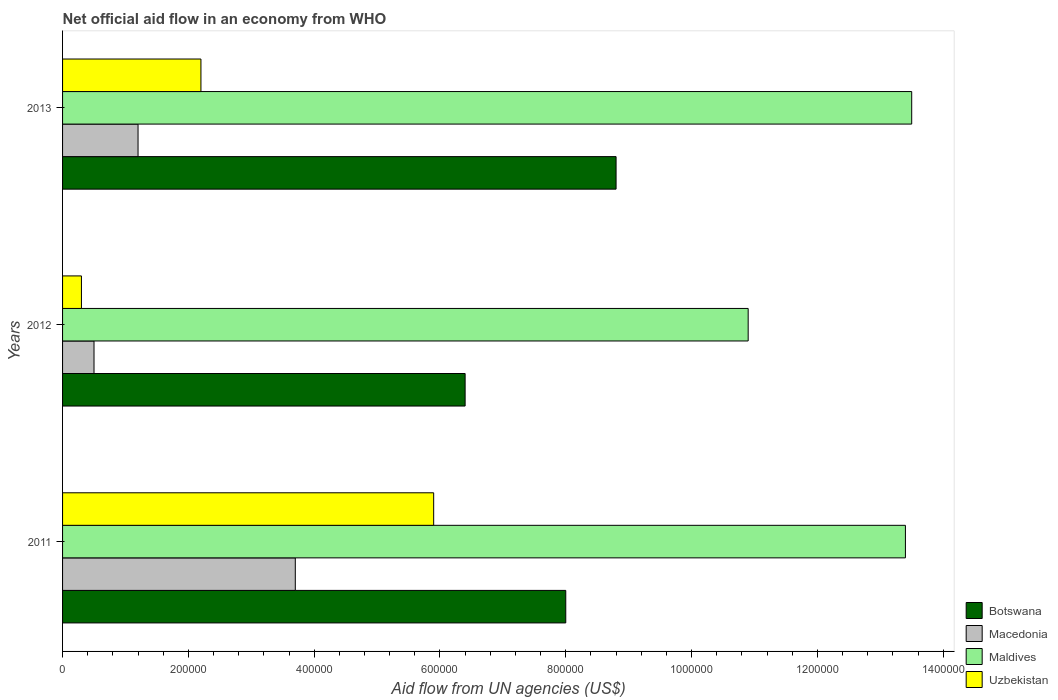How many different coloured bars are there?
Your answer should be very brief. 4. Are the number of bars per tick equal to the number of legend labels?
Keep it short and to the point. Yes. Are the number of bars on each tick of the Y-axis equal?
Provide a short and direct response. Yes. How many bars are there on the 3rd tick from the top?
Provide a short and direct response. 4. How many bars are there on the 1st tick from the bottom?
Your response must be concise. 4. What is the label of the 1st group of bars from the top?
Offer a terse response. 2013. In how many cases, is the number of bars for a given year not equal to the number of legend labels?
Provide a short and direct response. 0. What is the net official aid flow in Uzbekistan in 2013?
Your answer should be very brief. 2.20e+05. Across all years, what is the maximum net official aid flow in Maldives?
Your answer should be compact. 1.35e+06. What is the total net official aid flow in Maldives in the graph?
Offer a very short reply. 3.78e+06. What is the difference between the net official aid flow in Botswana in 2011 and that in 2013?
Your answer should be very brief. -8.00e+04. What is the difference between the net official aid flow in Uzbekistan in 2011 and the net official aid flow in Macedonia in 2012?
Ensure brevity in your answer.  5.40e+05. What is the average net official aid flow in Maldives per year?
Keep it short and to the point. 1.26e+06. What is the ratio of the net official aid flow in Botswana in 2011 to that in 2013?
Your answer should be very brief. 0.91. What is the difference between the highest and the second highest net official aid flow in Botswana?
Your response must be concise. 8.00e+04. Is the sum of the net official aid flow in Maldives in 2011 and 2013 greater than the maximum net official aid flow in Macedonia across all years?
Provide a short and direct response. Yes. Is it the case that in every year, the sum of the net official aid flow in Maldives and net official aid flow in Uzbekistan is greater than the sum of net official aid flow in Macedonia and net official aid flow in Botswana?
Your answer should be compact. Yes. What does the 1st bar from the top in 2011 represents?
Offer a terse response. Uzbekistan. What does the 4th bar from the bottom in 2012 represents?
Provide a short and direct response. Uzbekistan. Are all the bars in the graph horizontal?
Provide a succinct answer. Yes. How many years are there in the graph?
Keep it short and to the point. 3. Are the values on the major ticks of X-axis written in scientific E-notation?
Offer a terse response. No. Does the graph contain any zero values?
Make the answer very short. No. Does the graph contain grids?
Your answer should be very brief. No. What is the title of the graph?
Keep it short and to the point. Net official aid flow in an economy from WHO. Does "Mongolia" appear as one of the legend labels in the graph?
Your response must be concise. No. What is the label or title of the X-axis?
Offer a very short reply. Aid flow from UN agencies (US$). What is the label or title of the Y-axis?
Your answer should be compact. Years. What is the Aid flow from UN agencies (US$) in Botswana in 2011?
Give a very brief answer. 8.00e+05. What is the Aid flow from UN agencies (US$) of Maldives in 2011?
Keep it short and to the point. 1.34e+06. What is the Aid flow from UN agencies (US$) of Uzbekistan in 2011?
Provide a succinct answer. 5.90e+05. What is the Aid flow from UN agencies (US$) in Botswana in 2012?
Your response must be concise. 6.40e+05. What is the Aid flow from UN agencies (US$) in Maldives in 2012?
Your answer should be very brief. 1.09e+06. What is the Aid flow from UN agencies (US$) of Botswana in 2013?
Make the answer very short. 8.80e+05. What is the Aid flow from UN agencies (US$) of Maldives in 2013?
Keep it short and to the point. 1.35e+06. What is the Aid flow from UN agencies (US$) of Uzbekistan in 2013?
Your answer should be very brief. 2.20e+05. Across all years, what is the maximum Aid flow from UN agencies (US$) of Botswana?
Offer a terse response. 8.80e+05. Across all years, what is the maximum Aid flow from UN agencies (US$) of Maldives?
Provide a succinct answer. 1.35e+06. Across all years, what is the maximum Aid flow from UN agencies (US$) in Uzbekistan?
Make the answer very short. 5.90e+05. Across all years, what is the minimum Aid flow from UN agencies (US$) of Botswana?
Give a very brief answer. 6.40e+05. Across all years, what is the minimum Aid flow from UN agencies (US$) in Macedonia?
Your answer should be compact. 5.00e+04. Across all years, what is the minimum Aid flow from UN agencies (US$) of Maldives?
Offer a terse response. 1.09e+06. Across all years, what is the minimum Aid flow from UN agencies (US$) in Uzbekistan?
Make the answer very short. 3.00e+04. What is the total Aid flow from UN agencies (US$) of Botswana in the graph?
Provide a short and direct response. 2.32e+06. What is the total Aid flow from UN agencies (US$) of Macedonia in the graph?
Make the answer very short. 5.40e+05. What is the total Aid flow from UN agencies (US$) in Maldives in the graph?
Provide a short and direct response. 3.78e+06. What is the total Aid flow from UN agencies (US$) of Uzbekistan in the graph?
Offer a terse response. 8.40e+05. What is the difference between the Aid flow from UN agencies (US$) in Botswana in 2011 and that in 2012?
Offer a terse response. 1.60e+05. What is the difference between the Aid flow from UN agencies (US$) in Macedonia in 2011 and that in 2012?
Offer a very short reply. 3.20e+05. What is the difference between the Aid flow from UN agencies (US$) in Uzbekistan in 2011 and that in 2012?
Your response must be concise. 5.60e+05. What is the difference between the Aid flow from UN agencies (US$) in Botswana in 2011 and that in 2013?
Ensure brevity in your answer.  -8.00e+04. What is the difference between the Aid flow from UN agencies (US$) of Macedonia in 2011 and that in 2013?
Offer a terse response. 2.50e+05. What is the difference between the Aid flow from UN agencies (US$) of Maldives in 2011 and that in 2013?
Ensure brevity in your answer.  -10000. What is the difference between the Aid flow from UN agencies (US$) in Macedonia in 2012 and that in 2013?
Your answer should be very brief. -7.00e+04. What is the difference between the Aid flow from UN agencies (US$) of Botswana in 2011 and the Aid flow from UN agencies (US$) of Macedonia in 2012?
Your answer should be compact. 7.50e+05. What is the difference between the Aid flow from UN agencies (US$) of Botswana in 2011 and the Aid flow from UN agencies (US$) of Maldives in 2012?
Ensure brevity in your answer.  -2.90e+05. What is the difference between the Aid flow from UN agencies (US$) of Botswana in 2011 and the Aid flow from UN agencies (US$) of Uzbekistan in 2012?
Offer a very short reply. 7.70e+05. What is the difference between the Aid flow from UN agencies (US$) of Macedonia in 2011 and the Aid flow from UN agencies (US$) of Maldives in 2012?
Your answer should be compact. -7.20e+05. What is the difference between the Aid flow from UN agencies (US$) of Maldives in 2011 and the Aid flow from UN agencies (US$) of Uzbekistan in 2012?
Give a very brief answer. 1.31e+06. What is the difference between the Aid flow from UN agencies (US$) of Botswana in 2011 and the Aid flow from UN agencies (US$) of Macedonia in 2013?
Your answer should be very brief. 6.80e+05. What is the difference between the Aid flow from UN agencies (US$) in Botswana in 2011 and the Aid flow from UN agencies (US$) in Maldives in 2013?
Make the answer very short. -5.50e+05. What is the difference between the Aid flow from UN agencies (US$) of Botswana in 2011 and the Aid flow from UN agencies (US$) of Uzbekistan in 2013?
Keep it short and to the point. 5.80e+05. What is the difference between the Aid flow from UN agencies (US$) in Macedonia in 2011 and the Aid flow from UN agencies (US$) in Maldives in 2013?
Your response must be concise. -9.80e+05. What is the difference between the Aid flow from UN agencies (US$) in Macedonia in 2011 and the Aid flow from UN agencies (US$) in Uzbekistan in 2013?
Provide a short and direct response. 1.50e+05. What is the difference between the Aid flow from UN agencies (US$) in Maldives in 2011 and the Aid flow from UN agencies (US$) in Uzbekistan in 2013?
Provide a succinct answer. 1.12e+06. What is the difference between the Aid flow from UN agencies (US$) in Botswana in 2012 and the Aid flow from UN agencies (US$) in Macedonia in 2013?
Ensure brevity in your answer.  5.20e+05. What is the difference between the Aid flow from UN agencies (US$) in Botswana in 2012 and the Aid flow from UN agencies (US$) in Maldives in 2013?
Your answer should be very brief. -7.10e+05. What is the difference between the Aid flow from UN agencies (US$) of Macedonia in 2012 and the Aid flow from UN agencies (US$) of Maldives in 2013?
Keep it short and to the point. -1.30e+06. What is the difference between the Aid flow from UN agencies (US$) in Maldives in 2012 and the Aid flow from UN agencies (US$) in Uzbekistan in 2013?
Give a very brief answer. 8.70e+05. What is the average Aid flow from UN agencies (US$) in Botswana per year?
Ensure brevity in your answer.  7.73e+05. What is the average Aid flow from UN agencies (US$) of Maldives per year?
Ensure brevity in your answer.  1.26e+06. What is the average Aid flow from UN agencies (US$) of Uzbekistan per year?
Offer a terse response. 2.80e+05. In the year 2011, what is the difference between the Aid flow from UN agencies (US$) of Botswana and Aid flow from UN agencies (US$) of Maldives?
Keep it short and to the point. -5.40e+05. In the year 2011, what is the difference between the Aid flow from UN agencies (US$) of Macedonia and Aid flow from UN agencies (US$) of Maldives?
Your answer should be compact. -9.70e+05. In the year 2011, what is the difference between the Aid flow from UN agencies (US$) of Maldives and Aid flow from UN agencies (US$) of Uzbekistan?
Your answer should be very brief. 7.50e+05. In the year 2012, what is the difference between the Aid flow from UN agencies (US$) in Botswana and Aid flow from UN agencies (US$) in Macedonia?
Make the answer very short. 5.90e+05. In the year 2012, what is the difference between the Aid flow from UN agencies (US$) of Botswana and Aid flow from UN agencies (US$) of Maldives?
Your answer should be very brief. -4.50e+05. In the year 2012, what is the difference between the Aid flow from UN agencies (US$) in Macedonia and Aid flow from UN agencies (US$) in Maldives?
Provide a short and direct response. -1.04e+06. In the year 2012, what is the difference between the Aid flow from UN agencies (US$) of Maldives and Aid flow from UN agencies (US$) of Uzbekistan?
Ensure brevity in your answer.  1.06e+06. In the year 2013, what is the difference between the Aid flow from UN agencies (US$) of Botswana and Aid flow from UN agencies (US$) of Macedonia?
Offer a terse response. 7.60e+05. In the year 2013, what is the difference between the Aid flow from UN agencies (US$) in Botswana and Aid flow from UN agencies (US$) in Maldives?
Offer a very short reply. -4.70e+05. In the year 2013, what is the difference between the Aid flow from UN agencies (US$) of Botswana and Aid flow from UN agencies (US$) of Uzbekistan?
Offer a terse response. 6.60e+05. In the year 2013, what is the difference between the Aid flow from UN agencies (US$) of Macedonia and Aid flow from UN agencies (US$) of Maldives?
Your answer should be compact. -1.23e+06. In the year 2013, what is the difference between the Aid flow from UN agencies (US$) of Maldives and Aid flow from UN agencies (US$) of Uzbekistan?
Ensure brevity in your answer.  1.13e+06. What is the ratio of the Aid flow from UN agencies (US$) in Botswana in 2011 to that in 2012?
Offer a very short reply. 1.25. What is the ratio of the Aid flow from UN agencies (US$) in Maldives in 2011 to that in 2012?
Your response must be concise. 1.23. What is the ratio of the Aid flow from UN agencies (US$) of Uzbekistan in 2011 to that in 2012?
Your response must be concise. 19.67. What is the ratio of the Aid flow from UN agencies (US$) in Botswana in 2011 to that in 2013?
Offer a terse response. 0.91. What is the ratio of the Aid flow from UN agencies (US$) in Macedonia in 2011 to that in 2013?
Make the answer very short. 3.08. What is the ratio of the Aid flow from UN agencies (US$) in Uzbekistan in 2011 to that in 2013?
Your answer should be very brief. 2.68. What is the ratio of the Aid flow from UN agencies (US$) of Botswana in 2012 to that in 2013?
Offer a terse response. 0.73. What is the ratio of the Aid flow from UN agencies (US$) of Macedonia in 2012 to that in 2013?
Provide a short and direct response. 0.42. What is the ratio of the Aid flow from UN agencies (US$) of Maldives in 2012 to that in 2013?
Make the answer very short. 0.81. What is the ratio of the Aid flow from UN agencies (US$) in Uzbekistan in 2012 to that in 2013?
Keep it short and to the point. 0.14. What is the difference between the highest and the second highest Aid flow from UN agencies (US$) of Botswana?
Your answer should be compact. 8.00e+04. What is the difference between the highest and the second highest Aid flow from UN agencies (US$) of Maldives?
Offer a terse response. 10000. What is the difference between the highest and the lowest Aid flow from UN agencies (US$) in Botswana?
Make the answer very short. 2.40e+05. What is the difference between the highest and the lowest Aid flow from UN agencies (US$) of Maldives?
Ensure brevity in your answer.  2.60e+05. What is the difference between the highest and the lowest Aid flow from UN agencies (US$) of Uzbekistan?
Offer a terse response. 5.60e+05. 